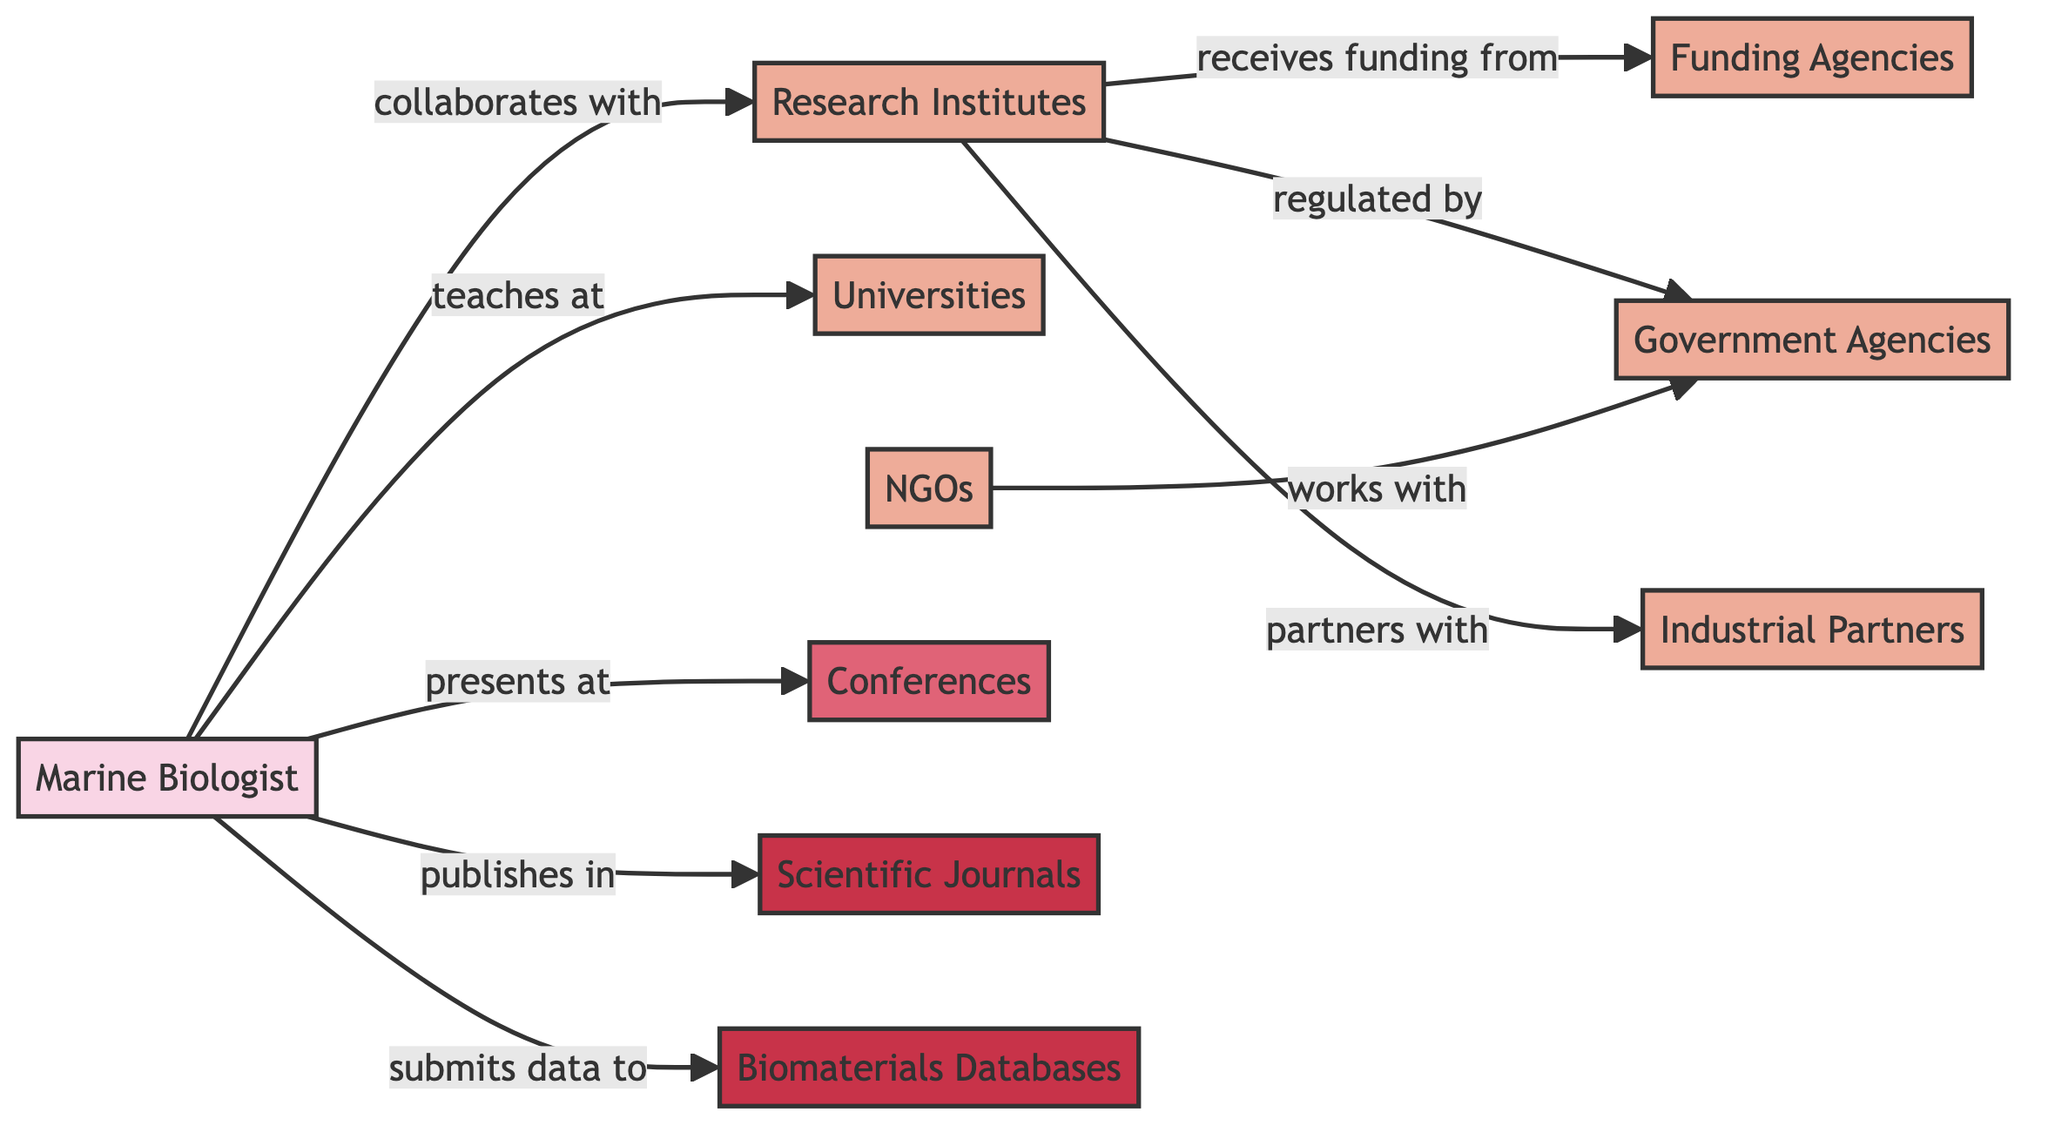What type of professional is represented by the node "Marine Biologist"? The node "Marine Biologist" describes a researcher specializing in sustainable biomaterials from marine organisms, which clearly indicates the profession.
Answer: researcher specializing in sustainable biomaterials from marine organisms How many organizations are present in the diagram? By counting the nodes of type "organization," we can identify that there are six organizations: Research Institutes, Universities, Funding Agencies, Industrial Partners, Government Agencies, and NGOs.
Answer: 6 What is the relationship between "Research Institutes" and "Funding Agencies"? The arrow directed from "Research Institutes" to "Funding Agencies" is labeled with "receives funding from," indicating a direct financial relationship where research institutes obtain funding from these agencies.
Answer: receives funding from Which node represents the event where findings are shared? The diagram includes a node labeled "Conferences," which is specifically described as an event where findings are shared and collaborations are formed, identifying it as the correct answer.
Answer: Conferences Which entity collaborates with the "Marine Biologist"? The outgoing edge from the "Marine Biologist" node leads to the "Research Institutes" node, indicating that marine biologists work alongside research institutes in their efforts.
Answer: Research Institutes What are the two types of resources listed in the diagram? The diagram has two nodes classified as resources: "Scientific Journals" and "Biomaterials Databases," which provide information dissemination and data repositories, respectively.
Answer: Scientific Journals, Biomaterials Databases How many edges are originating from the "Marine Biologist" node? By examining the outgoing connections from the "Marine Biologist" to other nodes, there are five distinct edges: to Research Institutes, Universities, Conferences, Journals, and Databases.
Answer: 5 Which organization is indicated to work with government agencies in the diagram? The flow from the "NGOs" node, directed towards the "Government Agencies" node, signifies that NGOs collaborate or coordinate efforts with these government entities.
Answer: NGOs How are "Research Institutes" regulated according to the diagram? The edge directed from "Research Institutes" to "Government Agencies" labeled "regulated by" indicates that government agencies oversee or are responsible for the regulation of research institutes.
Answer: regulated by 